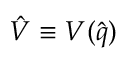<formula> <loc_0><loc_0><loc_500><loc_500>\hat { V } \equiv V ( \hat { q } )</formula> 